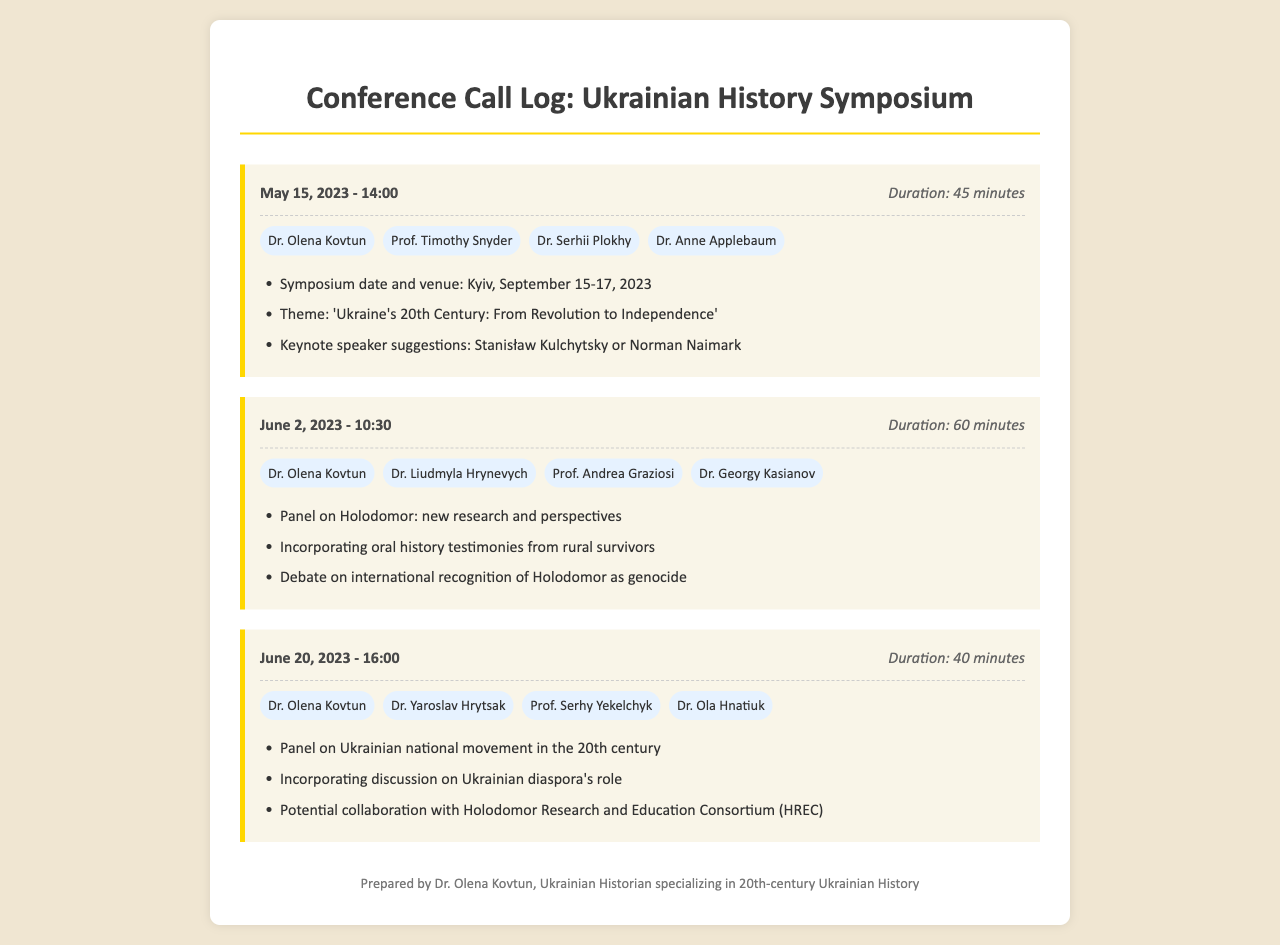What is the date of the symposium? The symposium is scheduled to take place from September 15 to 17, 2023, as mentioned in the first call log.
Answer: September 15-17, 2023 Who suggested the keynote speakers during the first conference call? The first call log includes suggestions for keynote speakers from the participants, specifically Stanisław Kulchytsky or Norman Naimark.
Answer: Stanisław Kulchytsky or Norman Naimark How long did the call on June 2, 2023, last? The call duration for June 2, 2023, is stated as 60 minutes in the corresponding call log.
Answer: 60 minutes Which historian participated in all three calls? By reviewing the list of participants in each call, it is evident that Dr. Olena Kovtun participated in all three conference calls.
Answer: Dr. Olena Kovtun What was one of the topics discussed during the June 20, 2023, call? The June 20 call log outlines several topics, one of which is the Panel on the Ukrainian national movement in the 20th century.
Answer: Panel on Ukrainian national movement in the 20th century What is the theme of the symposium? The theme of the symposium is stated in the first call log as 'Ukraine's 20th Century: From Revolution to Independence'.
Answer: Ukraine's 20th Century: From Revolution to Independence How many participants were in the call on June 2, 2023? The call on June 2, 2023, included four participants, as listed in the call log.
Answer: Four participants What was the specific focus of the second call? The second call focused on the panel discussing the Holodomor, including new research and perspectives.
Answer: Panel on Holodomor: new research and perspectives 